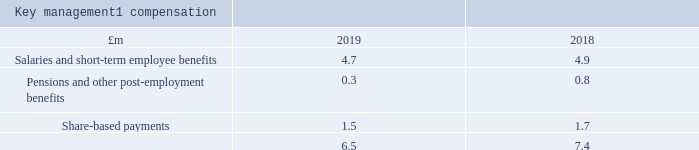35 Related party transactions
Key management1 compensation
1 Key management comprises the directors of intu properties plc and the Executive Committee who have been designated as persons discharging managerial responsibility (PDMR).
During 2017 the Group’s joint ventures in intu Puerto Venecia and intu Asturias sold shares in subsidiaries, previously wholly owned by the respective joint ventures, listed on the Spanish MaB to PDMRs of the Group. The total value of the shares at 31 December 2019 is €1.0 million for each joint venture, representing 1 per cent of the respective outstanding share capital. The sale of shares in these entities was required to comply with Spanish MaB free float listing requirements. The Group provided an interest-free loan to PDMRs to enable them to purchase the shares. The loans are treated as a taxable benefit which accordingly is included in the above table. In line with the terms of the relevant loan agreements entered into, the loans are repayable in full upon cessation of employment or the sale of the underlying assets. Further to the exchange of contracts in respect of the sale of intu Puerto Venecia in December 2019 and of intu Asturias in January 2020, the relevant PDMRs sold these shareholdings in January 2020 and February 2020 respectively. All outstanding loans in respect of the above arrangements have been repaid to the Company in full or in part. For those loans which have been partially repaid, the outstanding balance has been written off by the Company.
What does the key management comprise of? Directors of intu properties plc and the executive committee who have been designated as persons discharging managerial responsibility (pdmr). What is the total value of shares at 31 December 2019 for each joint venture? €1.0 million. What are the sale of shares in the entities required to comply with? Spanish mab free float listing requirements. What is the percentage change in the salaries and short-term employee benefits from 2018 to 2019?
Answer scale should be: percent. (4.7-4.9)/4.9
Answer: -4.08. What is the percentage change in the Pensions and other post-employment benefits from 2018 to 2019?
Answer scale should be: percent. (0.3-0.8)/0.8
Answer: -62.5. In which year is there a higher share-based payment? Find the year with the higher share-based payment
Answer: 2018. 